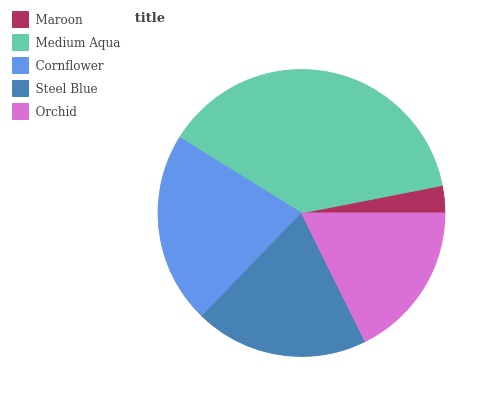Is Maroon the minimum?
Answer yes or no. Yes. Is Medium Aqua the maximum?
Answer yes or no. Yes. Is Cornflower the minimum?
Answer yes or no. No. Is Cornflower the maximum?
Answer yes or no. No. Is Medium Aqua greater than Cornflower?
Answer yes or no. Yes. Is Cornflower less than Medium Aqua?
Answer yes or no. Yes. Is Cornflower greater than Medium Aqua?
Answer yes or no. No. Is Medium Aqua less than Cornflower?
Answer yes or no. No. Is Steel Blue the high median?
Answer yes or no. Yes. Is Steel Blue the low median?
Answer yes or no. Yes. Is Orchid the high median?
Answer yes or no. No. Is Cornflower the low median?
Answer yes or no. No. 